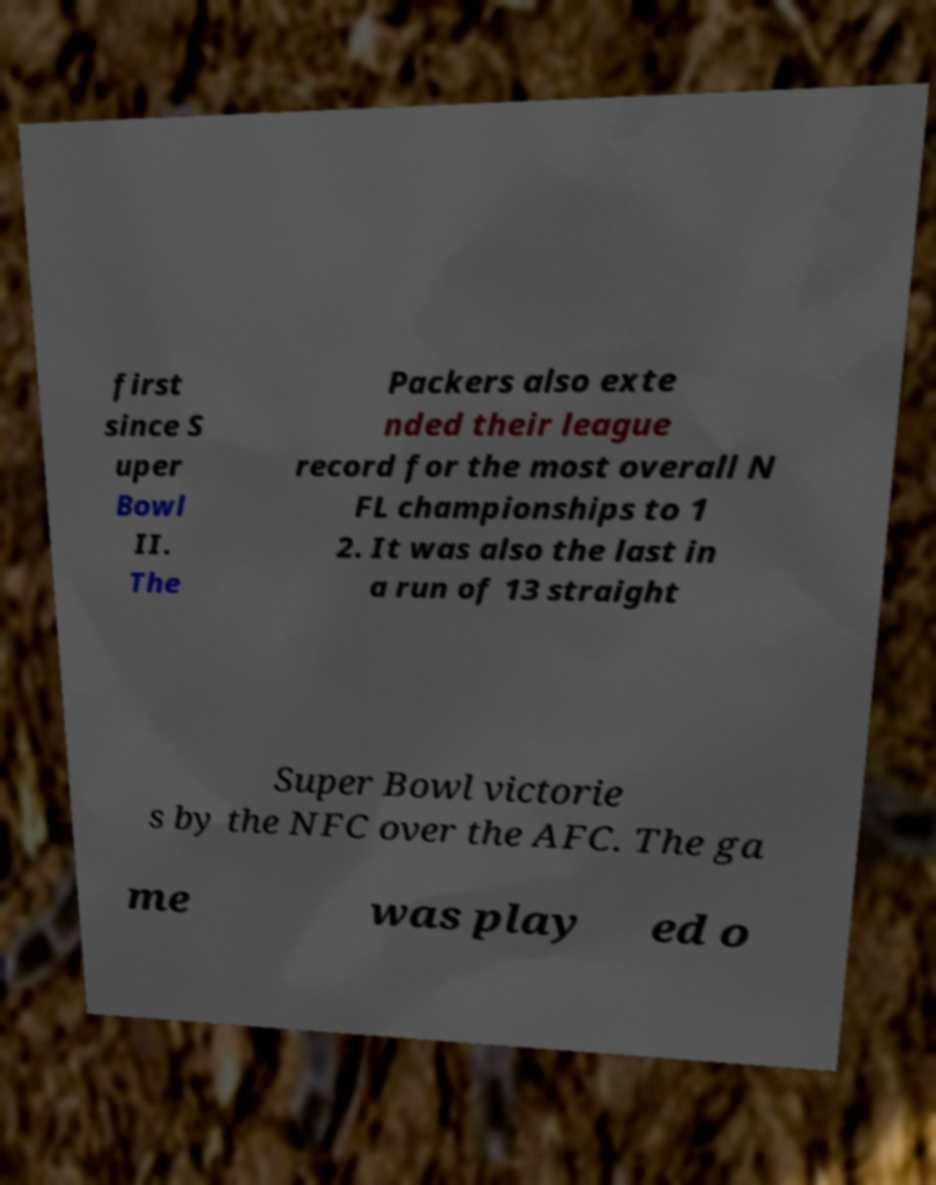There's text embedded in this image that I need extracted. Can you transcribe it verbatim? first since S uper Bowl II. The Packers also exte nded their league record for the most overall N FL championships to 1 2. It was also the last in a run of 13 straight Super Bowl victorie s by the NFC over the AFC. The ga me was play ed o 